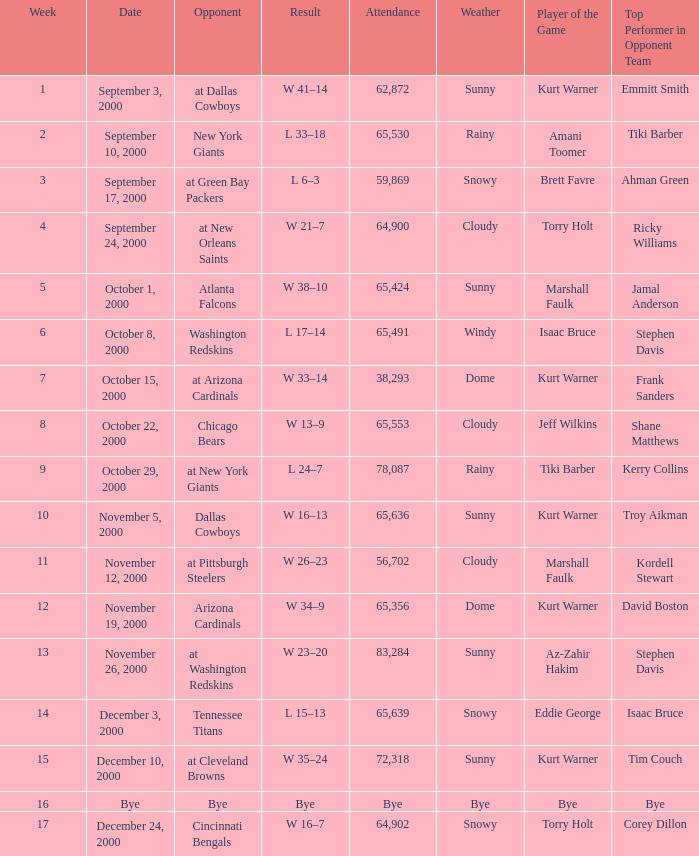What was the attendance when the Cincinnati Bengals were the opponents? 64902.0. Can you give me this table as a dict? {'header': ['Week', 'Date', 'Opponent', 'Result', 'Attendance', 'Weather', 'Player of the Game', 'Top Performer in Opponent Team'], 'rows': [['1', 'September 3, 2000', 'at Dallas Cowboys', 'W 41–14', '62,872', 'Sunny', 'Kurt Warner', 'Emmitt Smith'], ['2', 'September 10, 2000', 'New York Giants', 'L 33–18', '65,530', 'Rainy', 'Amani Toomer', 'Tiki Barber'], ['3', 'September 17, 2000', 'at Green Bay Packers', 'L 6–3', '59,869', 'Snowy', 'Brett Favre', 'Ahman Green'], ['4', 'September 24, 2000', 'at New Orleans Saints', 'W 21–7', '64,900', 'Cloudy', 'Torry Holt', 'Ricky Williams'], ['5', 'October 1, 2000', 'Atlanta Falcons', 'W 38–10', '65,424', 'Sunny', 'Marshall Faulk', 'Jamal Anderson'], ['6', 'October 8, 2000', 'Washington Redskins', 'L 17–14', '65,491', 'Windy', 'Isaac Bruce', 'Stephen Davis'], ['7', 'October 15, 2000', 'at Arizona Cardinals', 'W 33–14', '38,293', 'Dome', 'Kurt Warner', 'Frank Sanders'], ['8', 'October 22, 2000', 'Chicago Bears', 'W 13–9', '65,553', 'Cloudy', 'Jeff Wilkins', 'Shane Matthews'], ['9', 'October 29, 2000', 'at New York Giants', 'L 24–7', '78,087', 'Rainy', 'Tiki Barber', 'Kerry Collins'], ['10', 'November 5, 2000', 'Dallas Cowboys', 'W 16–13', '65,636', 'Sunny', 'Kurt Warner', 'Troy Aikman'], ['11', 'November 12, 2000', 'at Pittsburgh Steelers', 'W 26–23', '56,702', 'Cloudy', 'Marshall Faulk', 'Kordell Stewart'], ['12', 'November 19, 2000', 'Arizona Cardinals', 'W 34–9', '65,356', 'Dome', 'Kurt Warner', 'David Boston'], ['13', 'November 26, 2000', 'at Washington Redskins', 'W 23–20', '83,284', 'Sunny', 'Az-Zahir Hakim', 'Stephen Davis'], ['14', 'December 3, 2000', 'Tennessee Titans', 'L 15–13', '65,639', 'Snowy', 'Eddie George', 'Isaac Bruce'], ['15', 'December 10, 2000', 'at Cleveland Browns', 'W 35–24', '72,318', 'Sunny', 'Kurt Warner', 'Tim Couch'], ['16', 'Bye', 'Bye', 'Bye', 'Bye', 'Bye', 'Bye', 'Bye'], ['17', 'December 24, 2000', 'Cincinnati Bengals', 'W 16–7', '64,902', 'Snowy', 'Torry Holt', 'Corey Dillon']]} 